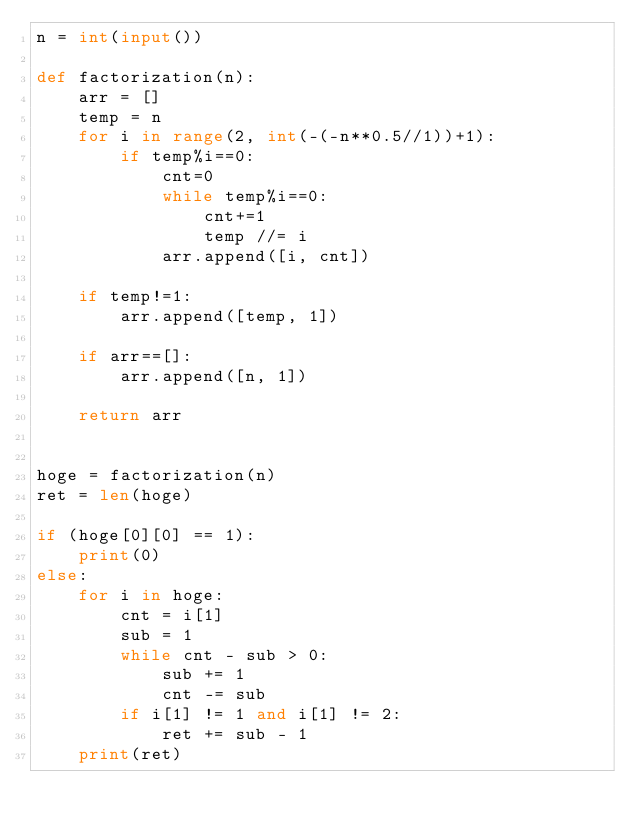<code> <loc_0><loc_0><loc_500><loc_500><_Python_>n = int(input())

def factorization(n):
    arr = []
    temp = n
    for i in range(2, int(-(-n**0.5//1))+1):
        if temp%i==0:
            cnt=0
            while temp%i==0:
                cnt+=1
                temp //= i
            arr.append([i, cnt])

    if temp!=1:
        arr.append([temp, 1])

    if arr==[]:
        arr.append([n, 1])

    return arr


hoge = factorization(n)
ret = len(hoge)

if (hoge[0][0] == 1):
    print(0)
else:
    for i in hoge:
        cnt = i[1]
        sub = 1
        while cnt - sub > 0:
            sub += 1
            cnt -= sub
        if i[1] != 1 and i[1] != 2:
            ret += sub - 1
    print(ret)
</code> 